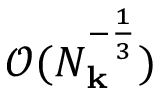Convert formula to latex. <formula><loc_0><loc_0><loc_500><loc_500>\mathcal { O } ( N _ { k } ^ { - \frac { 1 } { 3 } } )</formula> 